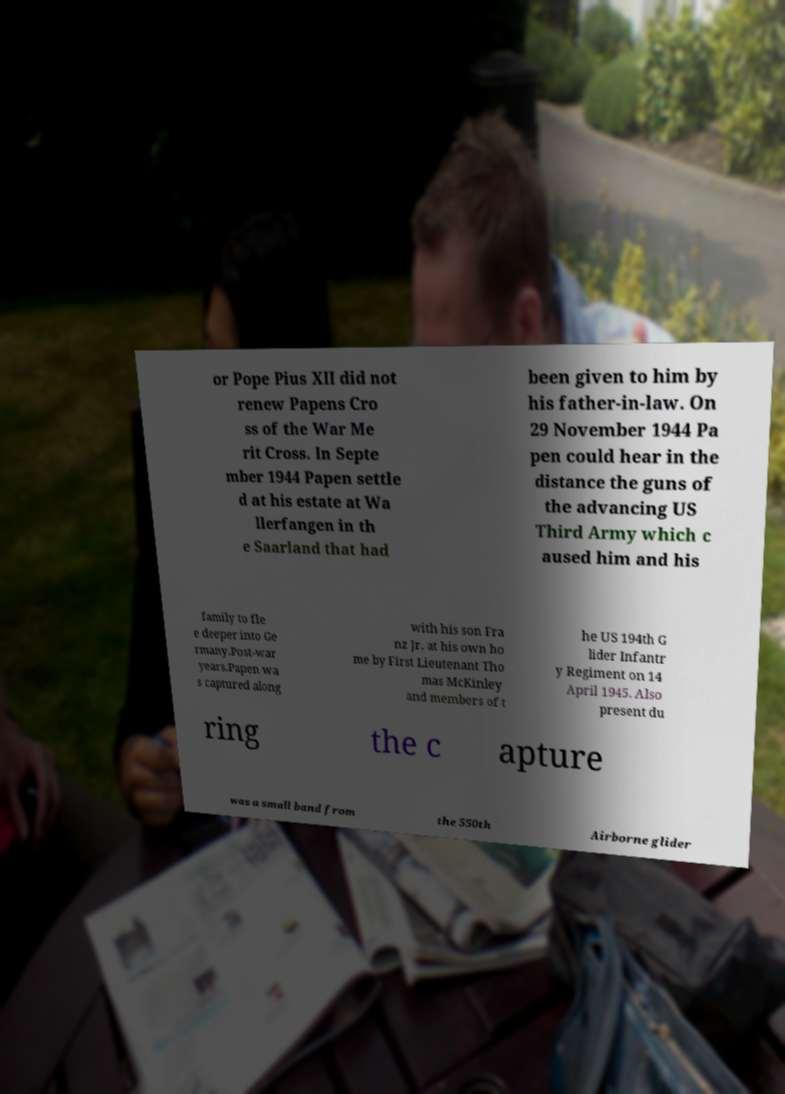Please identify and transcribe the text found in this image. or Pope Pius XII did not renew Papens Cro ss of the War Me rit Cross. In Septe mber 1944 Papen settle d at his estate at Wa llerfangen in th e Saarland that had been given to him by his father-in-law. On 29 November 1944 Pa pen could hear in the distance the guns of the advancing US Third Army which c aused him and his family to fle e deeper into Ge rmany.Post-war years.Papen wa s captured along with his son Fra nz Jr. at his own ho me by First Lieutenant Tho mas McKinley and members of t he US 194th G lider Infantr y Regiment on 14 April 1945. Also present du ring the c apture was a small band from the 550th Airborne glider 